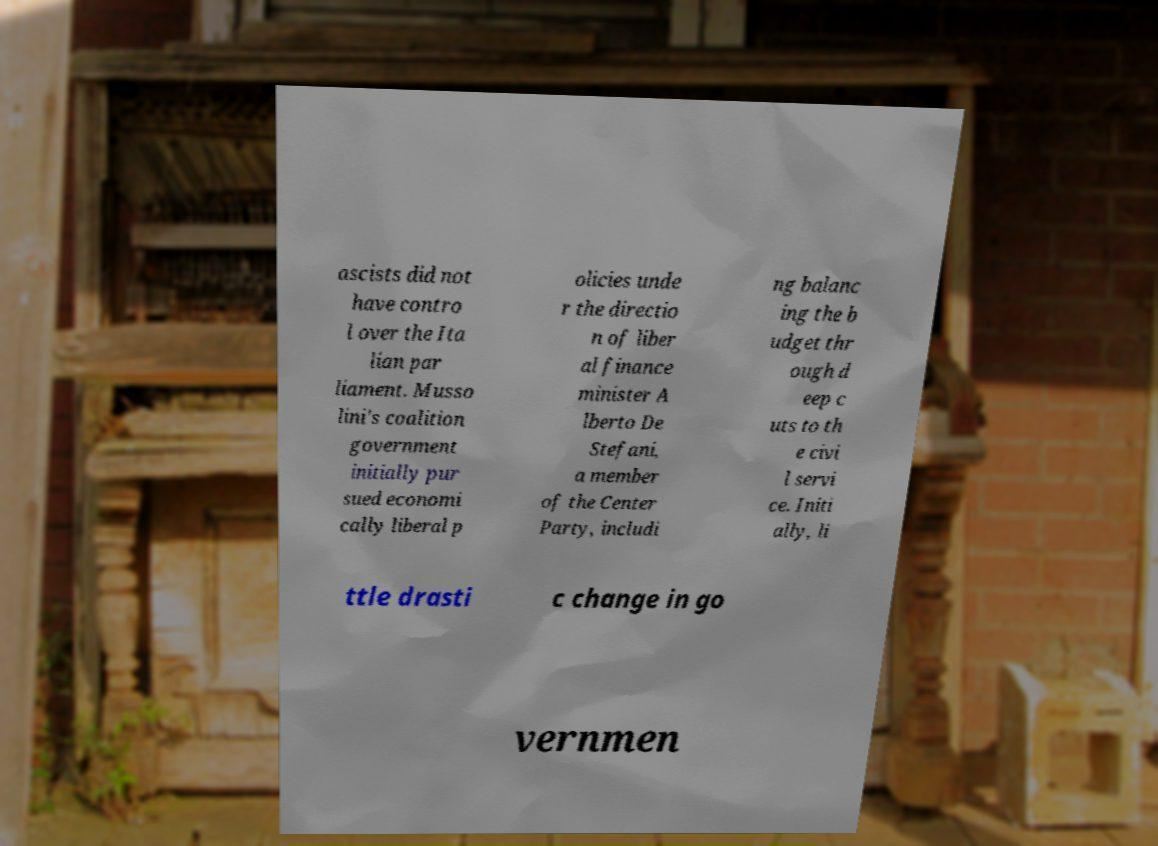Could you extract and type out the text from this image? ascists did not have contro l over the Ita lian par liament. Musso lini's coalition government initially pur sued economi cally liberal p olicies unde r the directio n of liber al finance minister A lberto De Stefani, a member of the Center Party, includi ng balanc ing the b udget thr ough d eep c uts to th e civi l servi ce. Initi ally, li ttle drasti c change in go vernmen 